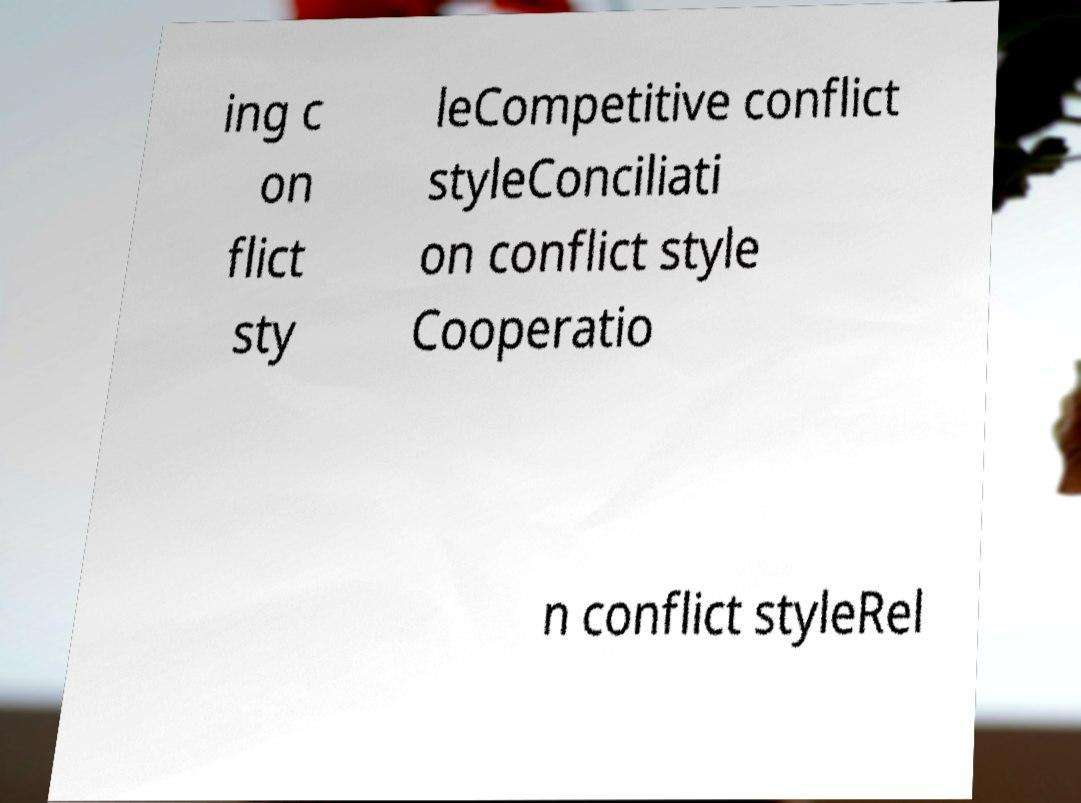Please read and relay the text visible in this image. What does it say? ing c on flict sty leCompetitive conflict styleConciliati on conflict style Cooperatio n conflict styleRel 